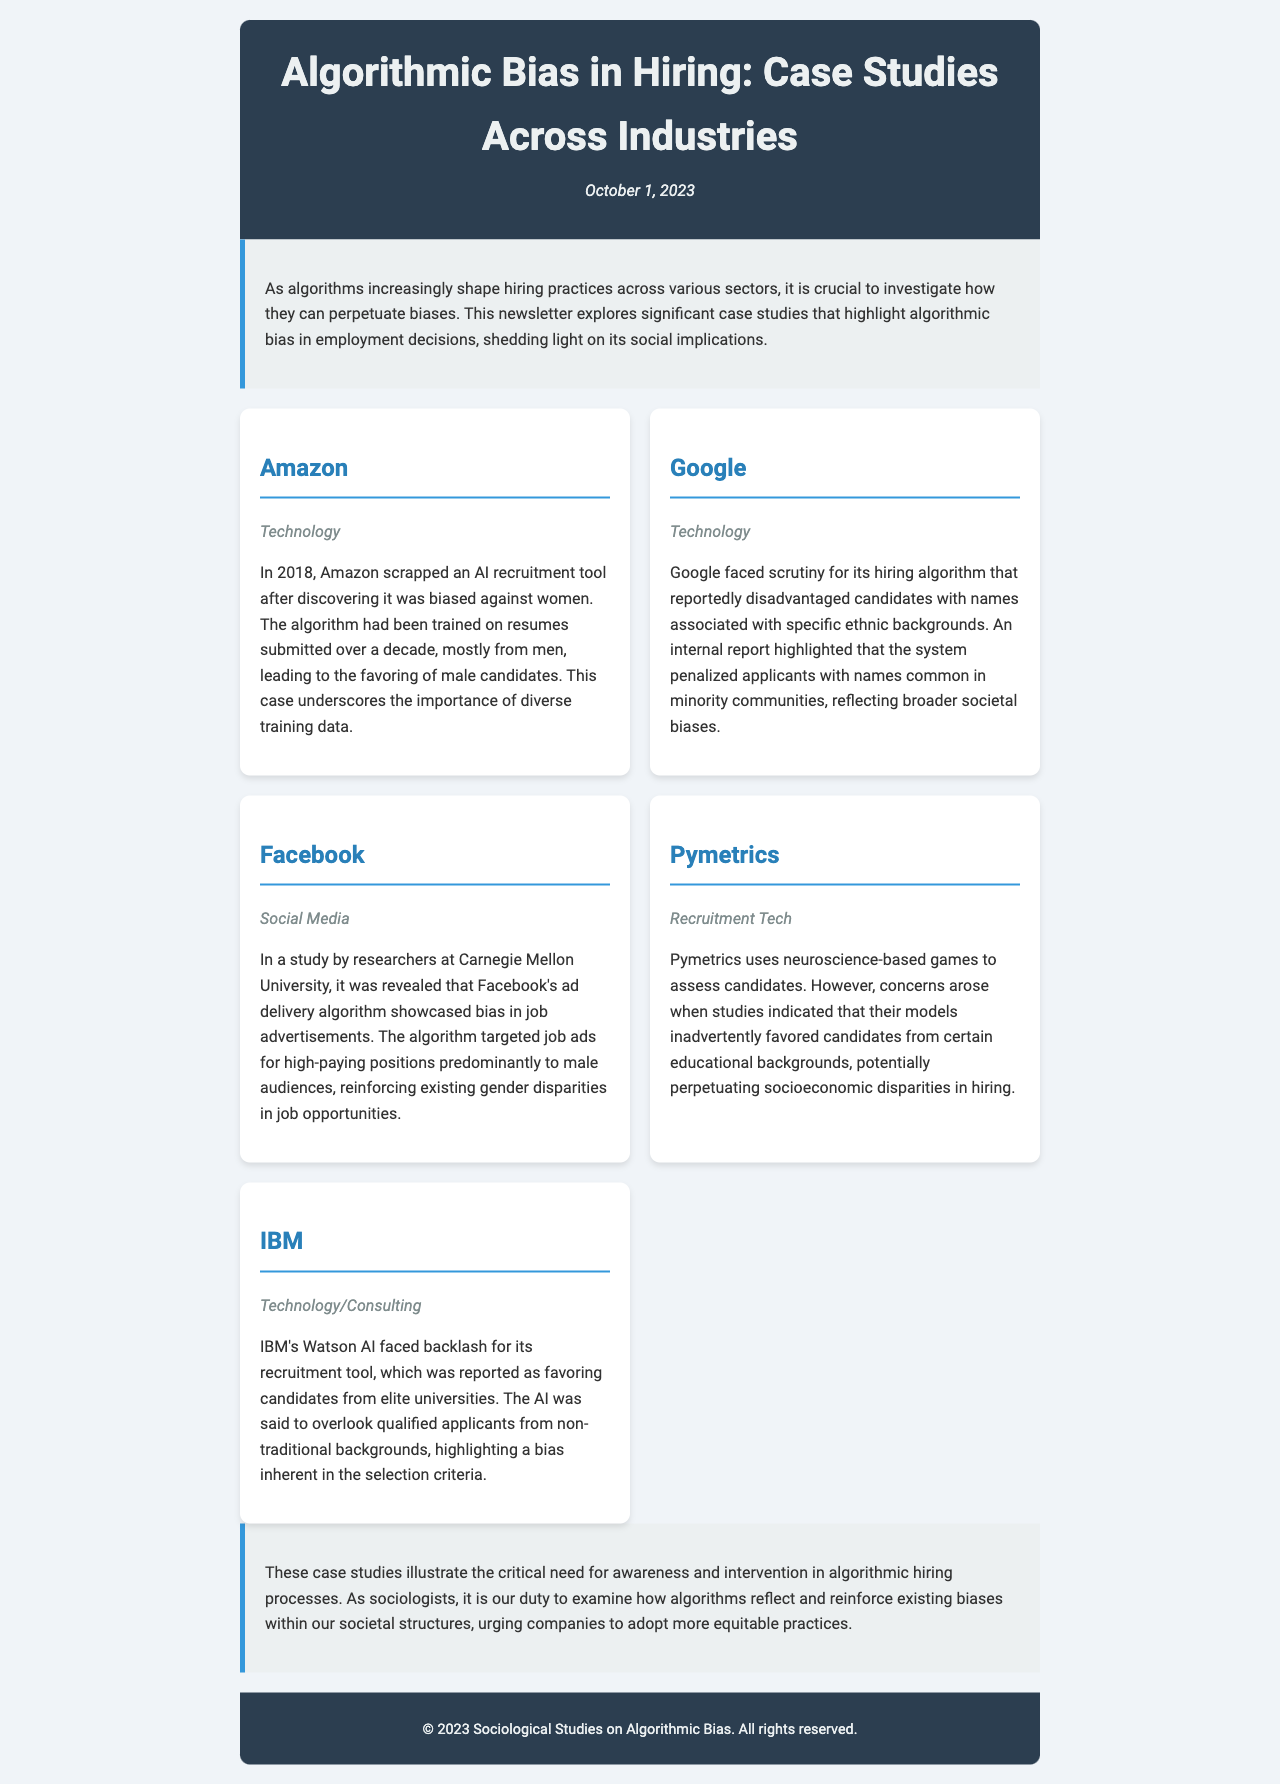what year did Amazon scrap its AI recruitment tool? The document states that Amazon scrapped its AI recruitment tool in 2018 after discovering bias against women.
Answer: 2018 which company faced scrutiny for its hiring algorithm penalizing applicants with certain names? The document highlights that Google faced scrutiny for penalizing candidates with names associated with specific ethnic backgrounds.
Answer: Google what bias did Facebook's ad delivery algorithm reinforce? According to the document, Facebook's ad delivery algorithm reinforced existing gender disparities in job opportunities by targeting male audiences predominantly.
Answer: Gender disparities what type of companies were highlighted in the case studies? The document includes case studies predominantly from companies within the technology and recruitment sectors, emphasizing their hiring practices.
Answer: Technology and Recruitment which company used neuroscience-based games to assess candidates? The document mentions that Pymetrics uses neuroscience-based games for candidate assessment, which drew concerns about bias.
Answer: Pymetrics what is the primary focus of this newsletter? The newsletter's primary focus is on investigating algorithmic bias in hiring practices across various sectors and its social implications.
Answer: Algorithmic bias in hiring what is one social implication discussed in the document regarding algorithms in hiring? The document discusses the critical need for awareness and intervention in algorithmic hiring processes, indicating their potential to reinforce existing societal biases.
Answer: Reinforce existing societal biases how does IBM's Watson recruitment tool bias candidates? According to the document, IBM's Watson AI was reported as favoring candidates from elite universities, which highlighted bias in its selection criteria.
Answer: Favoring candidates from elite universities what is the date of publication for this newsletter? The document provides the date of publication as October 1, 2023.
Answer: October 1, 2023 